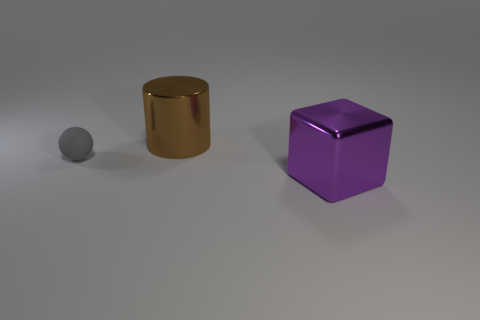Add 2 large metallic cylinders. How many objects exist? 5 Subtract all cubes. How many objects are left? 2 Subtract all red blocks. How many yellow cylinders are left? 0 Subtract all big cubes. Subtract all large brown rubber cubes. How many objects are left? 2 Add 3 metal cylinders. How many metal cylinders are left? 4 Add 2 small cyan balls. How many small cyan balls exist? 2 Subtract 1 purple cubes. How many objects are left? 2 Subtract 1 balls. How many balls are left? 0 Subtract all gray cylinders. Subtract all blue balls. How many cylinders are left? 1 